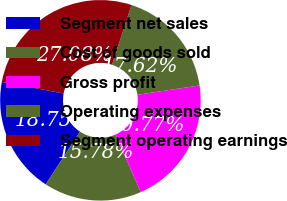Convert chart. <chart><loc_0><loc_0><loc_500><loc_500><pie_chart><fcel>Segment net sales<fcel>Cost of goods sold<fcel>Gross profit<fcel>Operating expenses<fcel>Segment operating earnings<nl><fcel>18.75%<fcel>15.78%<fcel>20.77%<fcel>17.62%<fcel>27.08%<nl></chart> 